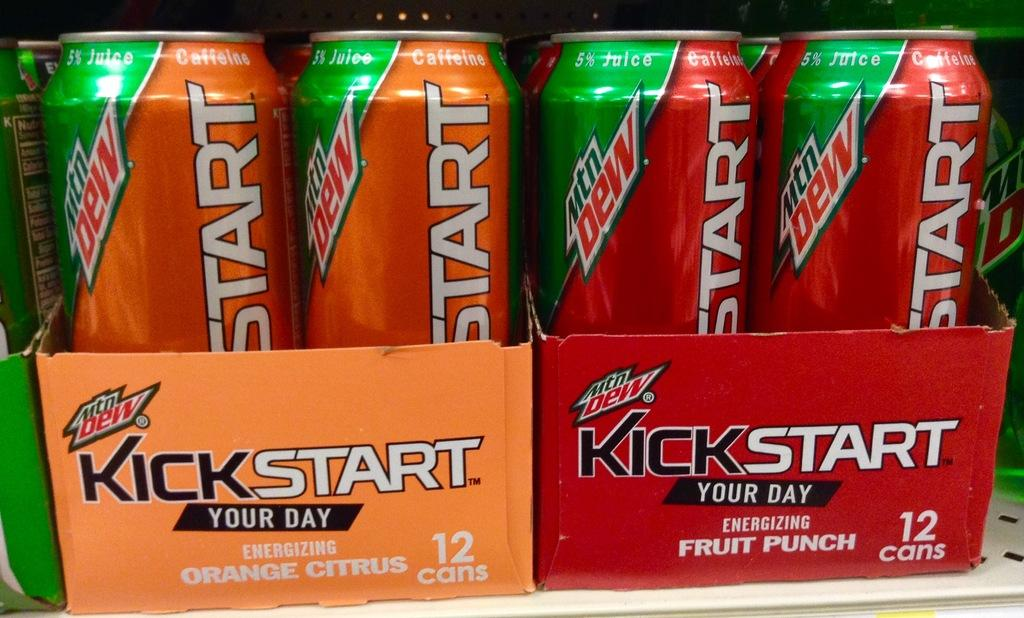Provide a one-sentence caption for the provided image. Two twelve packs of Kickstart in orange citrus and fruit punch. 